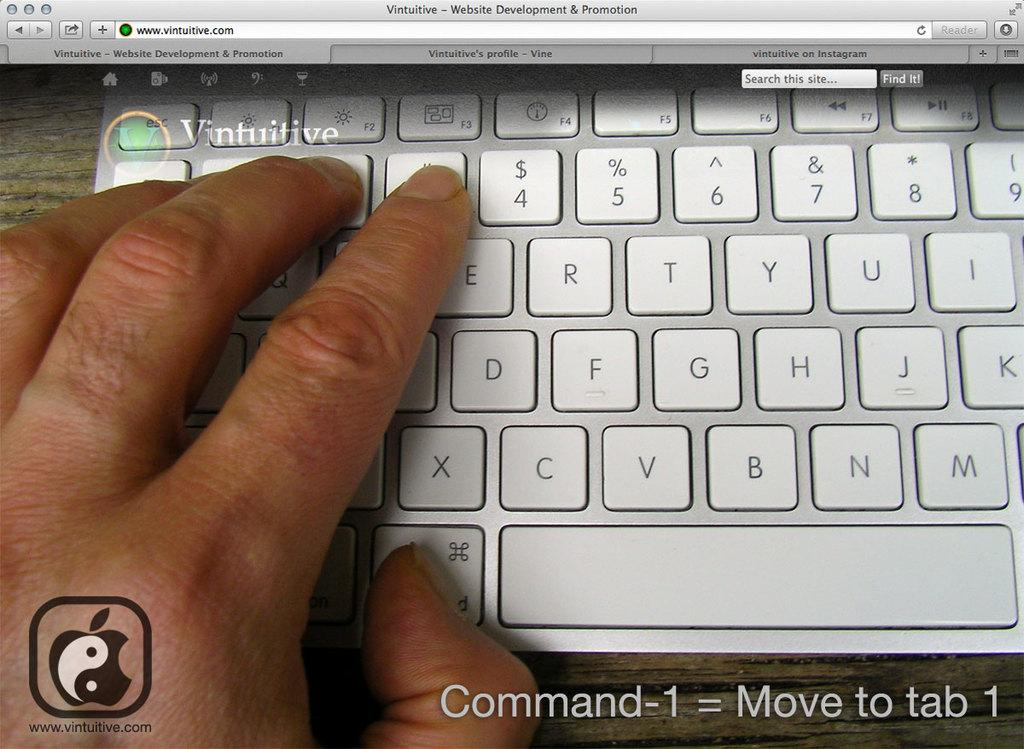<image>
Describe the image concisely. a silver keyboard in a picture that is labeled 'command-1=move to tab 1 